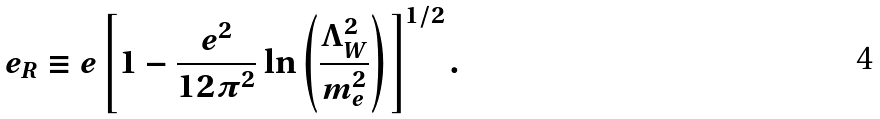<formula> <loc_0><loc_0><loc_500><loc_500>e _ { R } \equiv e \left [ 1 - \frac { e ^ { 2 } } { 1 2 \pi ^ { 2 } } \ln \left ( \frac { \Lambda _ { W } ^ { 2 } } { m _ { e } ^ { 2 } } \right ) \right ] ^ { 1 / 2 } .</formula> 